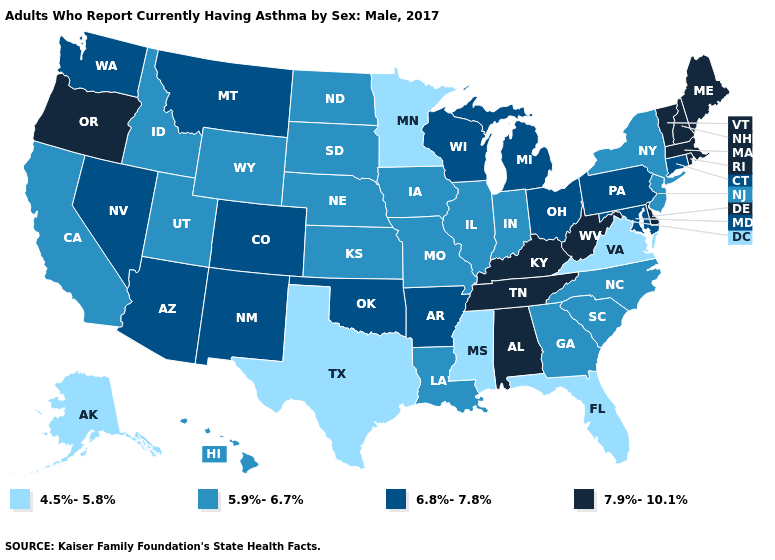How many symbols are there in the legend?
Concise answer only. 4. What is the value of Minnesota?
Short answer required. 4.5%-5.8%. What is the value of Montana?
Be succinct. 6.8%-7.8%. Does Georgia have the highest value in the USA?
Answer briefly. No. Among the states that border Montana , which have the lowest value?
Short answer required. Idaho, North Dakota, South Dakota, Wyoming. Does New Hampshire have a higher value than Kentucky?
Be succinct. No. What is the highest value in the South ?
Keep it brief. 7.9%-10.1%. Does New Hampshire have a higher value than New Mexico?
Be succinct. Yes. Which states have the lowest value in the USA?
Keep it brief. Alaska, Florida, Minnesota, Mississippi, Texas, Virginia. What is the value of Vermont?
Give a very brief answer. 7.9%-10.1%. Name the states that have a value in the range 4.5%-5.8%?
Keep it brief. Alaska, Florida, Minnesota, Mississippi, Texas, Virginia. What is the value of Iowa?
Be succinct. 5.9%-6.7%. Which states have the lowest value in the Northeast?
Be succinct. New Jersey, New York. How many symbols are there in the legend?
Concise answer only. 4. Does the map have missing data?
Answer briefly. No. 